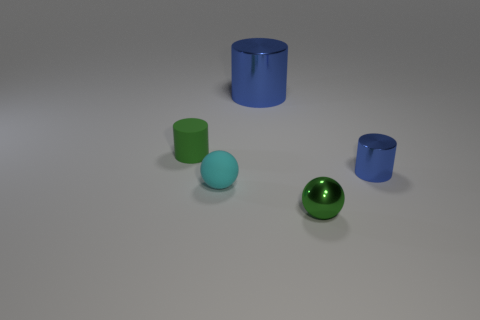Subtract all small cylinders. How many cylinders are left? 1 Subtract all green cylinders. How many cylinders are left? 2 Add 3 cyan matte balls. How many objects exist? 8 Subtract all cylinders. How many objects are left? 2 Subtract all purple balls. How many blue cylinders are left? 2 Subtract all big green things. Subtract all balls. How many objects are left? 3 Add 5 cyan rubber balls. How many cyan rubber balls are left? 6 Add 4 tiny metal things. How many tiny metal things exist? 6 Subtract 0 blue balls. How many objects are left? 5 Subtract all cyan cylinders. Subtract all yellow blocks. How many cylinders are left? 3 